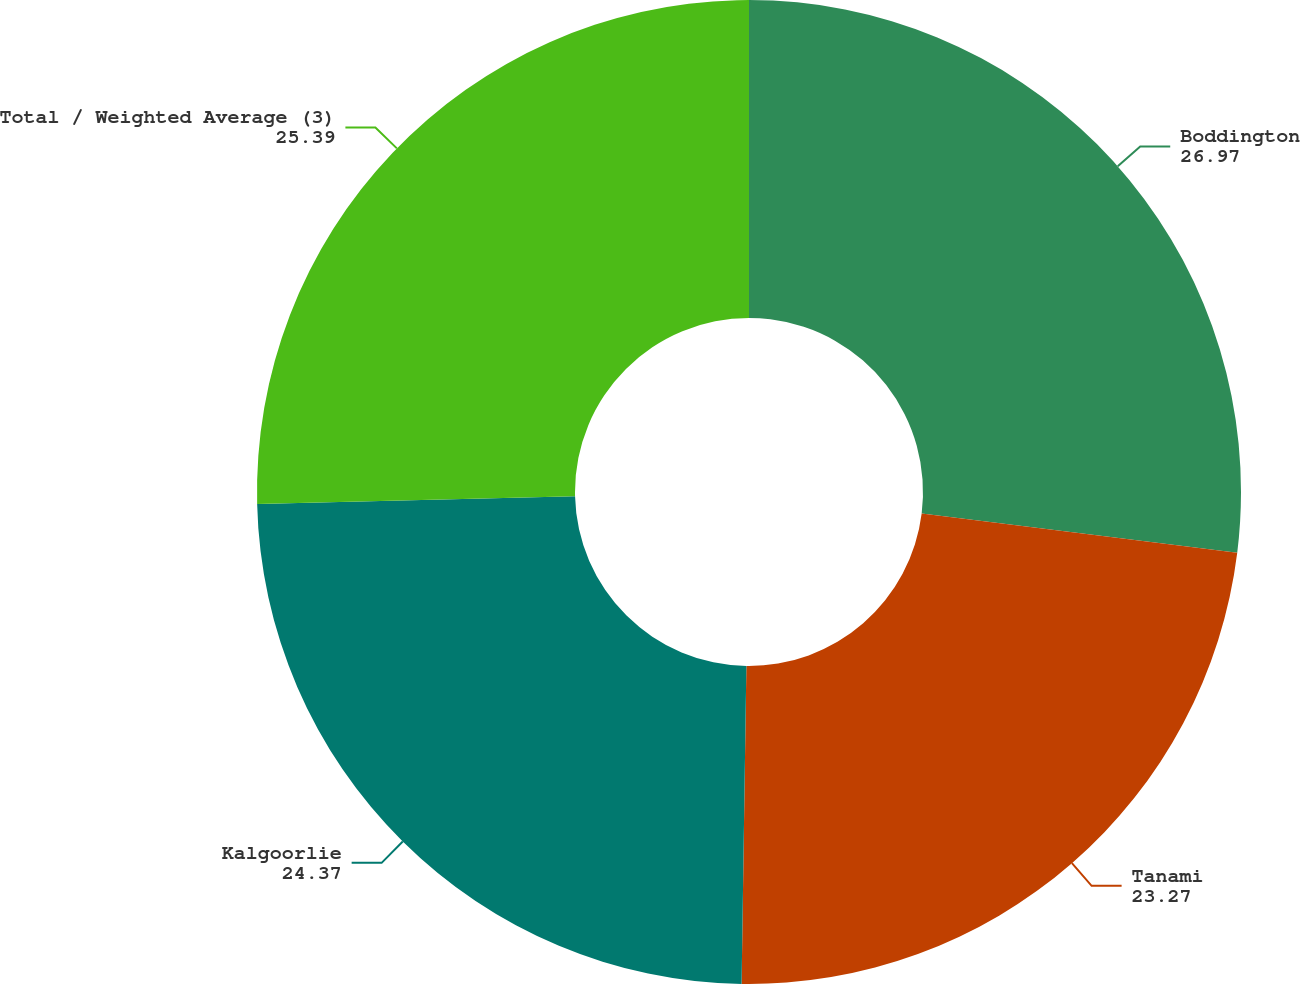<chart> <loc_0><loc_0><loc_500><loc_500><pie_chart><fcel>Boddington<fcel>Tanami<fcel>Kalgoorlie<fcel>Total / Weighted Average (3)<nl><fcel>26.97%<fcel>23.27%<fcel>24.37%<fcel>25.39%<nl></chart> 